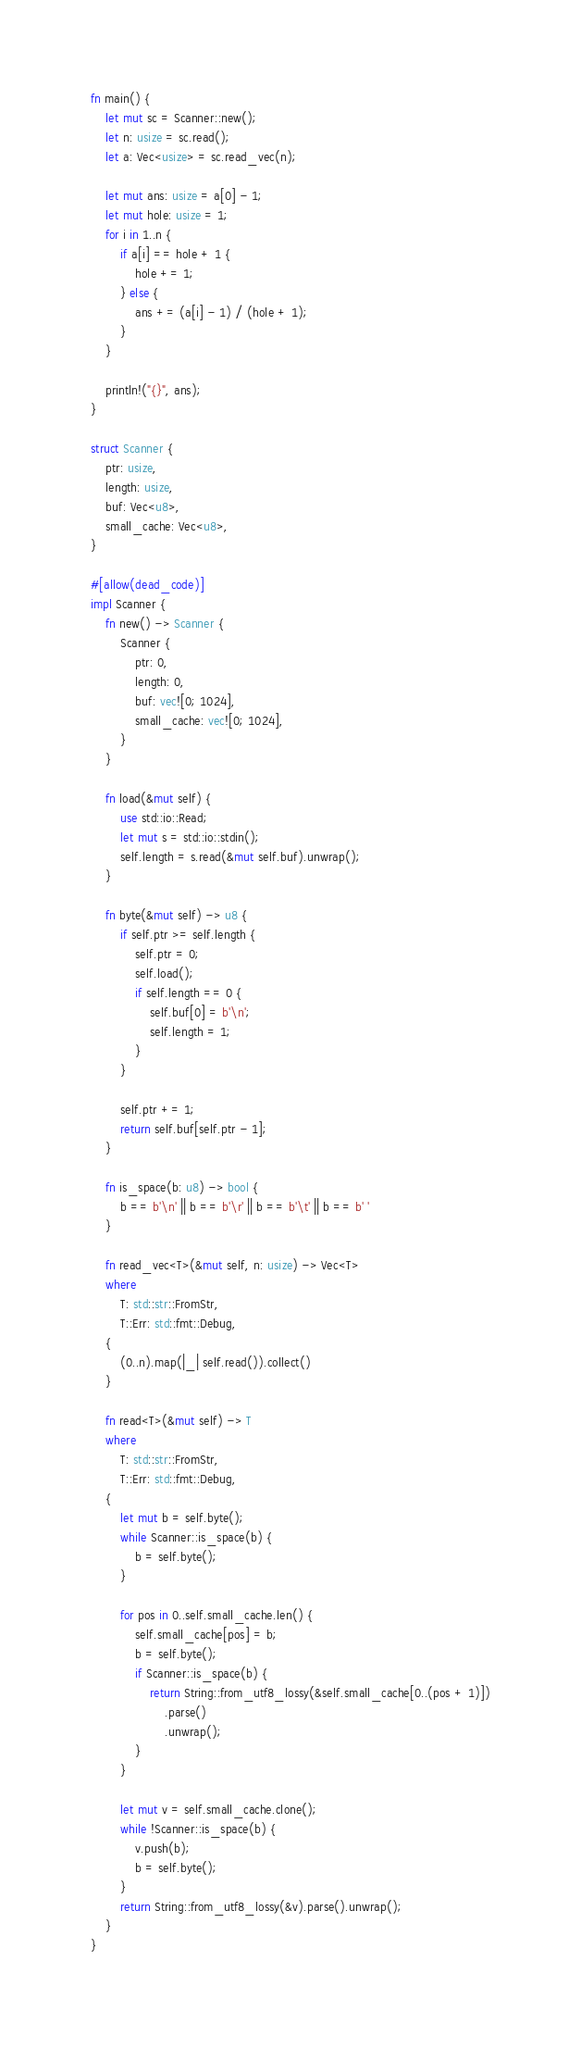<code> <loc_0><loc_0><loc_500><loc_500><_Rust_>fn main() {
    let mut sc = Scanner::new();
    let n: usize = sc.read();
    let a: Vec<usize> = sc.read_vec(n);

    let mut ans: usize = a[0] - 1;
    let mut hole: usize = 1;
    for i in 1..n {
        if a[i] == hole + 1 {
            hole += 1;
        } else {
            ans += (a[i] - 1) / (hole + 1);
        }
    }

    println!("{}", ans);
}

struct Scanner {
    ptr: usize,
    length: usize,
    buf: Vec<u8>,
    small_cache: Vec<u8>,
}

#[allow(dead_code)]
impl Scanner {
    fn new() -> Scanner {
        Scanner {
            ptr: 0,
            length: 0,
            buf: vec![0; 1024],
            small_cache: vec![0; 1024],
        }
    }

    fn load(&mut self) {
        use std::io::Read;
        let mut s = std::io::stdin();
        self.length = s.read(&mut self.buf).unwrap();
    }

    fn byte(&mut self) -> u8 {
        if self.ptr >= self.length {
            self.ptr = 0;
            self.load();
            if self.length == 0 {
                self.buf[0] = b'\n';
                self.length = 1;
            }
        }

        self.ptr += 1;
        return self.buf[self.ptr - 1];
    }

    fn is_space(b: u8) -> bool {
        b == b'\n' || b == b'\r' || b == b'\t' || b == b' '
    }

    fn read_vec<T>(&mut self, n: usize) -> Vec<T>
    where
        T: std::str::FromStr,
        T::Err: std::fmt::Debug,
    {
        (0..n).map(|_| self.read()).collect()
    }

    fn read<T>(&mut self) -> T
    where
        T: std::str::FromStr,
        T::Err: std::fmt::Debug,
    {
        let mut b = self.byte();
        while Scanner::is_space(b) {
            b = self.byte();
        }

        for pos in 0..self.small_cache.len() {
            self.small_cache[pos] = b;
            b = self.byte();
            if Scanner::is_space(b) {
                return String::from_utf8_lossy(&self.small_cache[0..(pos + 1)])
                    .parse()
                    .unwrap();
            }
        }

        let mut v = self.small_cache.clone();
        while !Scanner::is_space(b) {
            v.push(b);
            b = self.byte();
        }
        return String::from_utf8_lossy(&v).parse().unwrap();
    }
}
</code> 